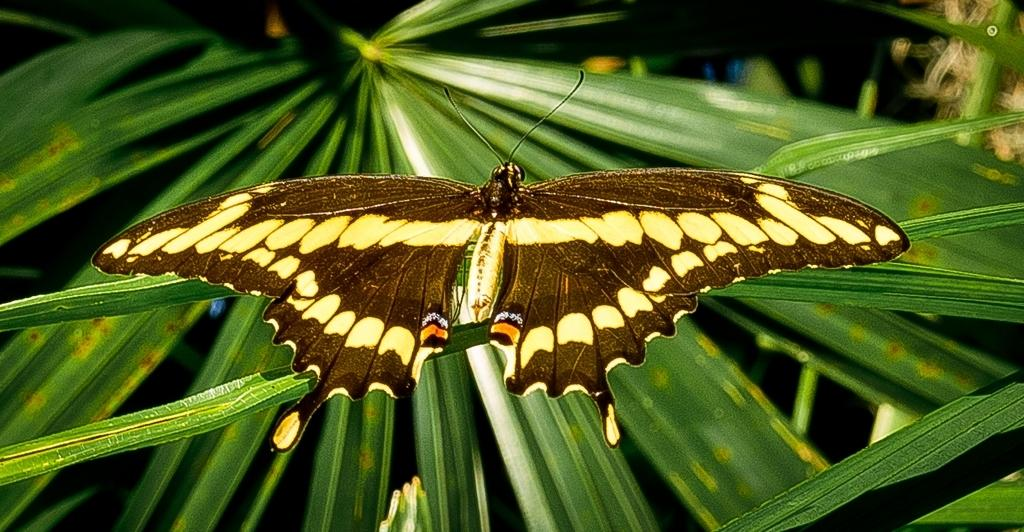What is the main subject of the image? There is a butterfly in the image. What is the butterfly doing in the image? The butterfly is standing on leaves. What can be seen in the background of the image? There are plants visible in the background of the image. What news is the butterfly sharing with the plants in the image? There is no indication in the image that the butterfly is sharing news with the plants. 